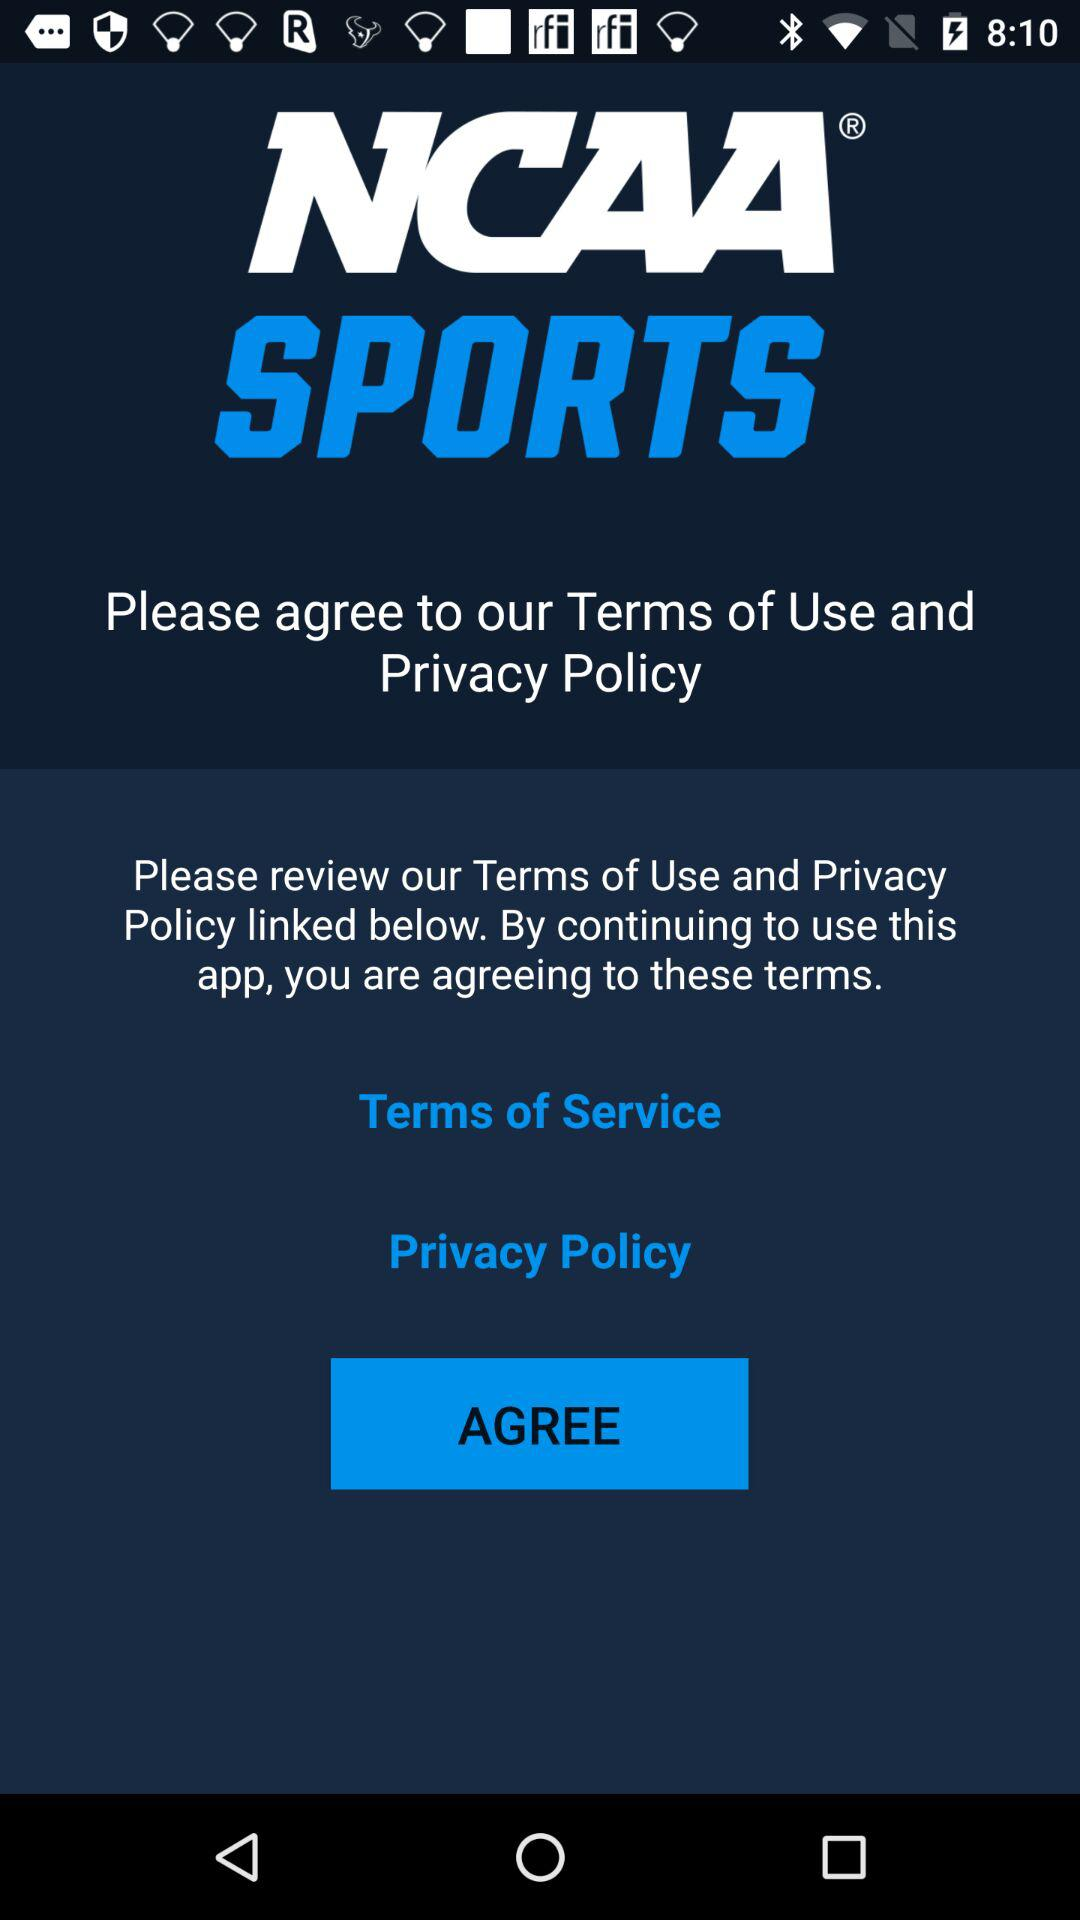What is the app title? The app title is "NCAA SPORTS". 